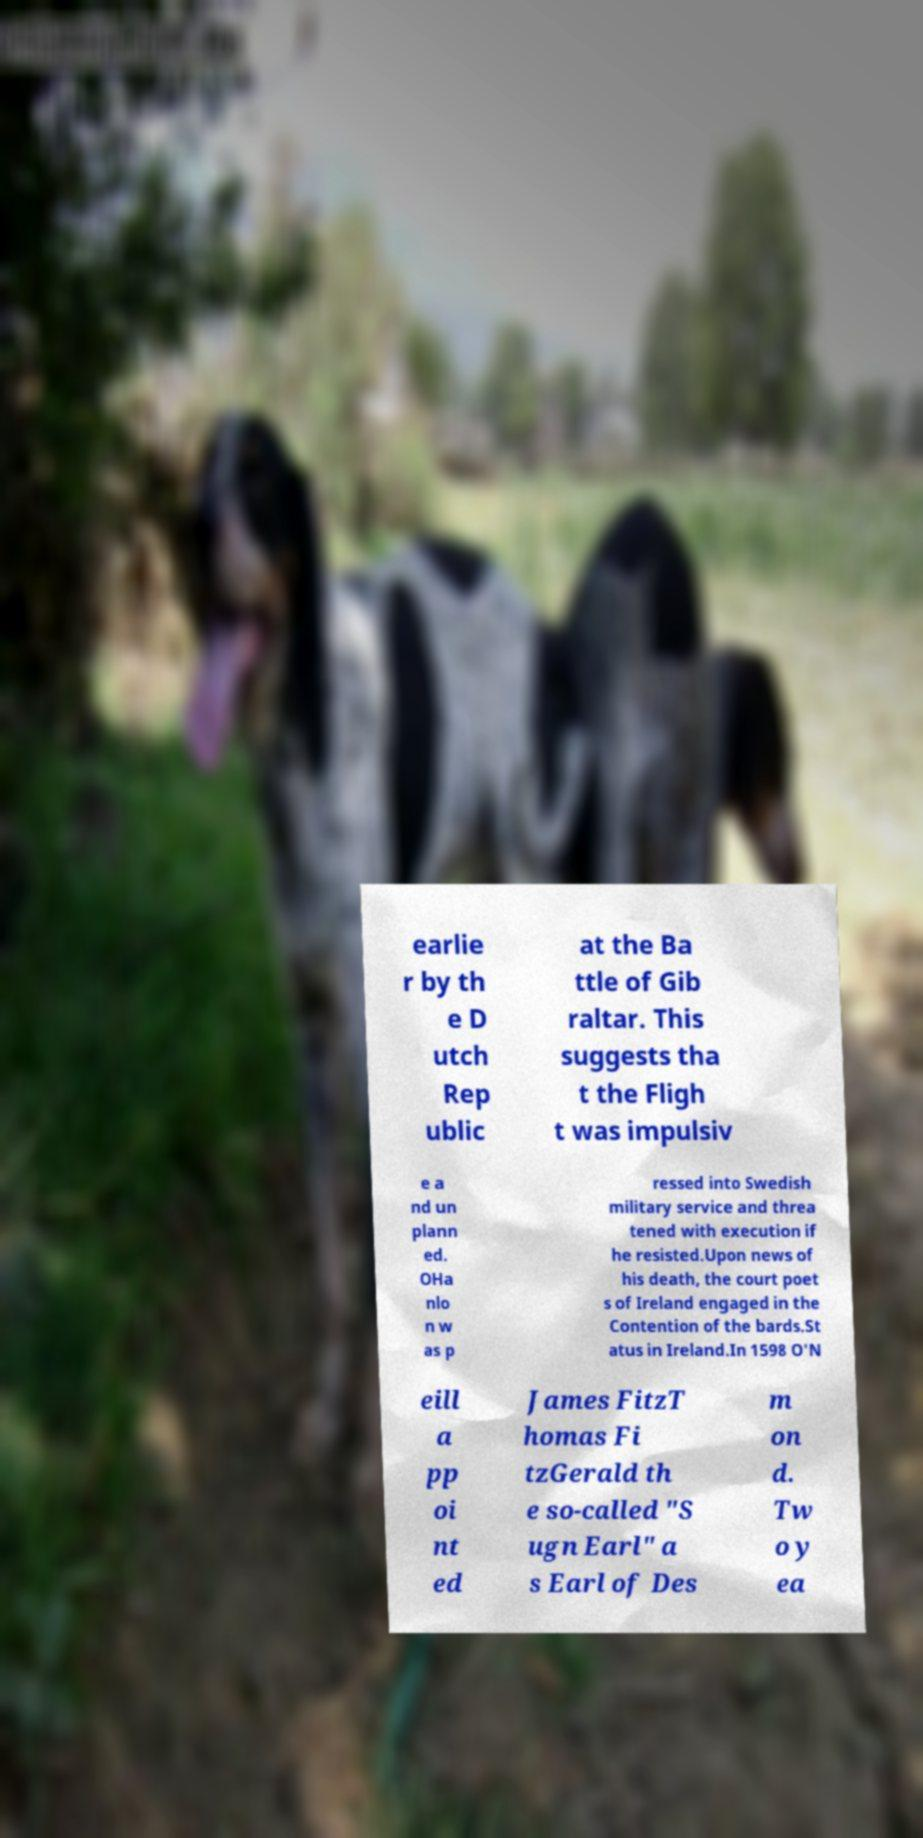Could you extract and type out the text from this image? earlie r by th e D utch Rep ublic at the Ba ttle of Gib raltar. This suggests tha t the Fligh t was impulsiv e a nd un plann ed. OHa nlo n w as p ressed into Swedish military service and threa tened with execution if he resisted.Upon news of his death, the court poet s of Ireland engaged in the Contention of the bards.St atus in Ireland.In 1598 O'N eill a pp oi nt ed James FitzT homas Fi tzGerald th e so-called "S ugn Earl" a s Earl of Des m on d. Tw o y ea 